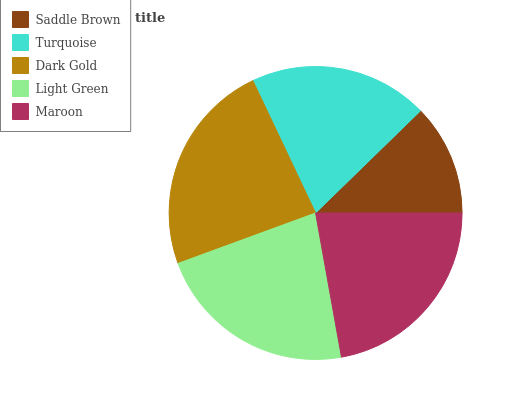Is Saddle Brown the minimum?
Answer yes or no. Yes. Is Dark Gold the maximum?
Answer yes or no. Yes. Is Turquoise the minimum?
Answer yes or no. No. Is Turquoise the maximum?
Answer yes or no. No. Is Turquoise greater than Saddle Brown?
Answer yes or no. Yes. Is Saddle Brown less than Turquoise?
Answer yes or no. Yes. Is Saddle Brown greater than Turquoise?
Answer yes or no. No. Is Turquoise less than Saddle Brown?
Answer yes or no. No. Is Maroon the high median?
Answer yes or no. Yes. Is Maroon the low median?
Answer yes or no. Yes. Is Dark Gold the high median?
Answer yes or no. No. Is Dark Gold the low median?
Answer yes or no. No. 